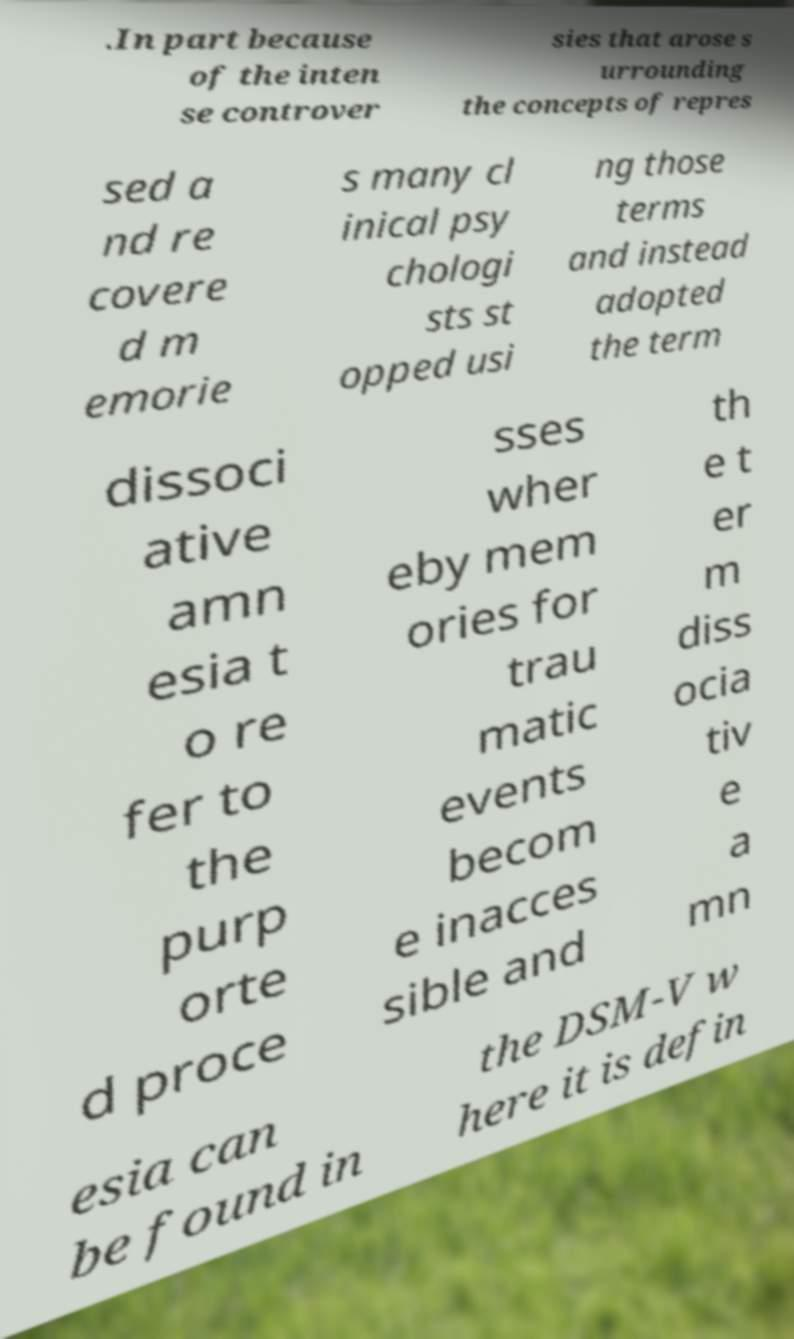Can you accurately transcribe the text from the provided image for me? .In part because of the inten se controver sies that arose s urrounding the concepts of repres sed a nd re covere d m emorie s many cl inical psy chologi sts st opped usi ng those terms and instead adopted the term dissoci ative amn esia t o re fer to the purp orte d proce sses wher eby mem ories for trau matic events becom e inacces sible and th e t er m diss ocia tiv e a mn esia can be found in the DSM-V w here it is defin 